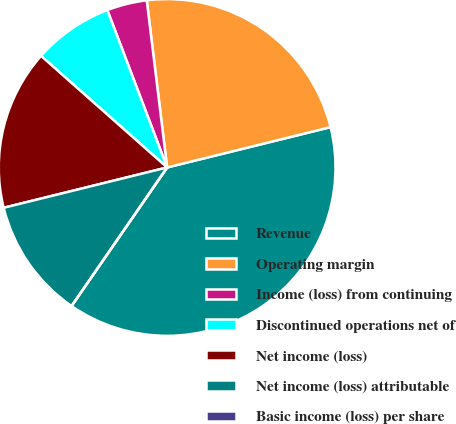<chart> <loc_0><loc_0><loc_500><loc_500><pie_chart><fcel>Revenue<fcel>Operating margin<fcel>Income (loss) from continuing<fcel>Discontinued operations net of<fcel>Net income (loss)<fcel>Net income (loss) attributable<fcel>Basic income (loss) per share<nl><fcel>38.46%<fcel>23.08%<fcel>3.85%<fcel>7.69%<fcel>15.38%<fcel>11.54%<fcel>0.0%<nl></chart> 